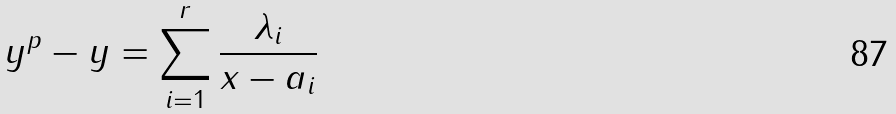<formula> <loc_0><loc_0><loc_500><loc_500>y ^ { p } - y = \sum _ { i = 1 } ^ { r } \frac { \lambda _ { i } } { x - a _ { i } }</formula> 